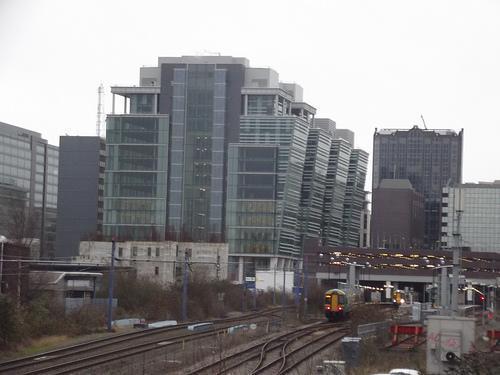How many clouds are in the sky?
Give a very brief answer. 0. 